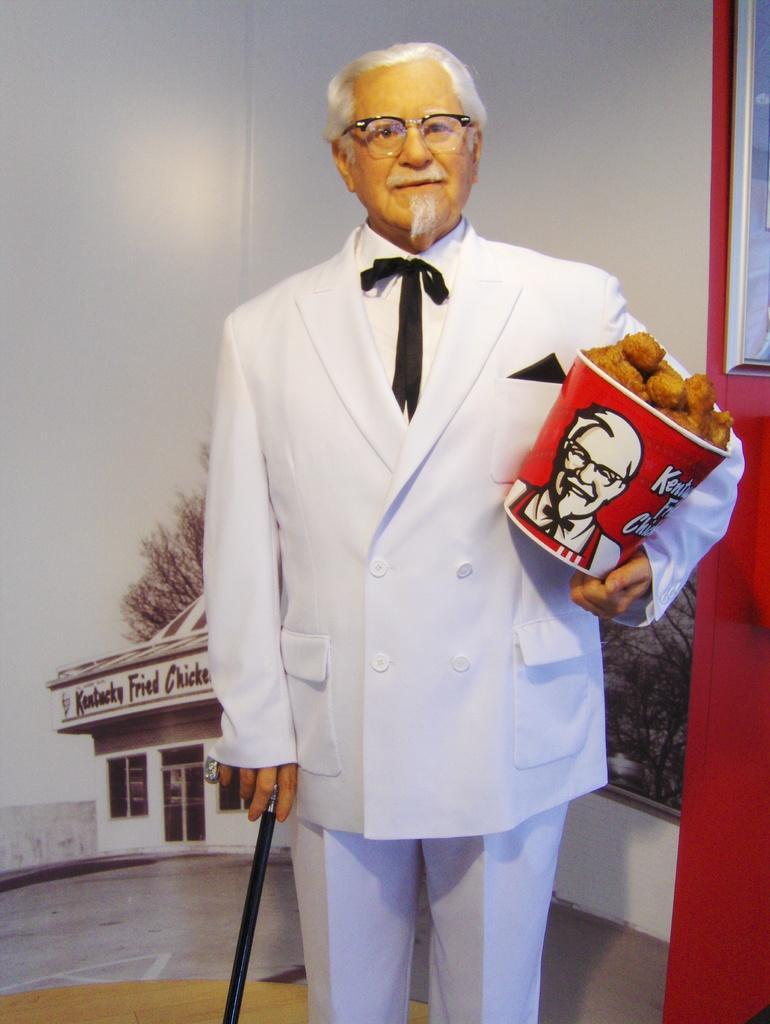Could you give a brief overview of what you see in this image? In this image I can see depiction of a man, I can see he is wearing white colour dress, specs and I can see he is holding a stick and a bucket. In this bucket I can see few brown colour things. In the background I can see few trees, a building and over there I can see something is written. 